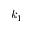<formula> <loc_0><loc_0><loc_500><loc_500>k _ { 1 }</formula> 